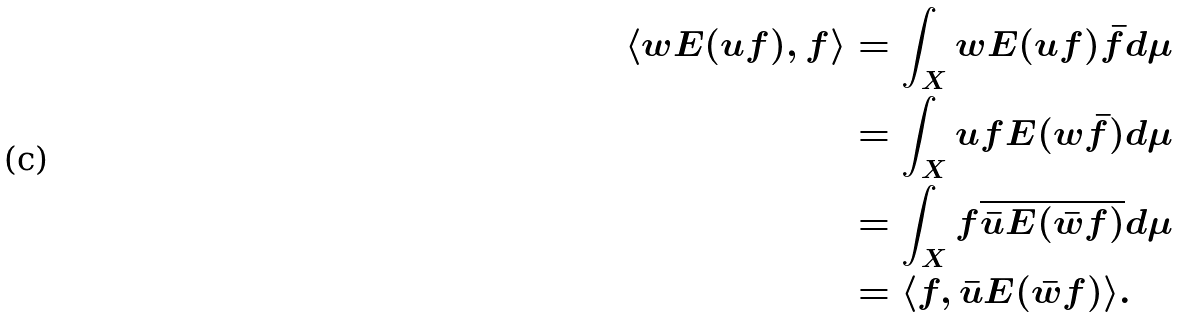Convert formula to latex. <formula><loc_0><loc_0><loc_500><loc_500>\langle w E ( u f ) , f \rangle & = \int _ { X } w E ( u f ) \bar { f } d \mu \\ & = \int _ { X } u f E ( w \bar { f } ) d \mu \\ & = \int _ { X } f \overline { \bar { u } E ( \bar { w } f ) } d \mu \\ & = \langle f , \bar { u } E ( \bar { w } f ) \rangle . \\</formula> 